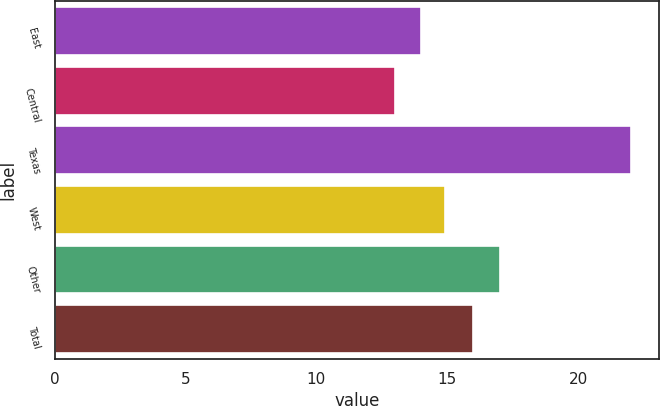Convert chart to OTSL. <chart><loc_0><loc_0><loc_500><loc_500><bar_chart><fcel>East<fcel>Central<fcel>Texas<fcel>West<fcel>Other<fcel>Total<nl><fcel>14<fcel>13<fcel>22<fcel>14.9<fcel>17<fcel>16<nl></chart> 